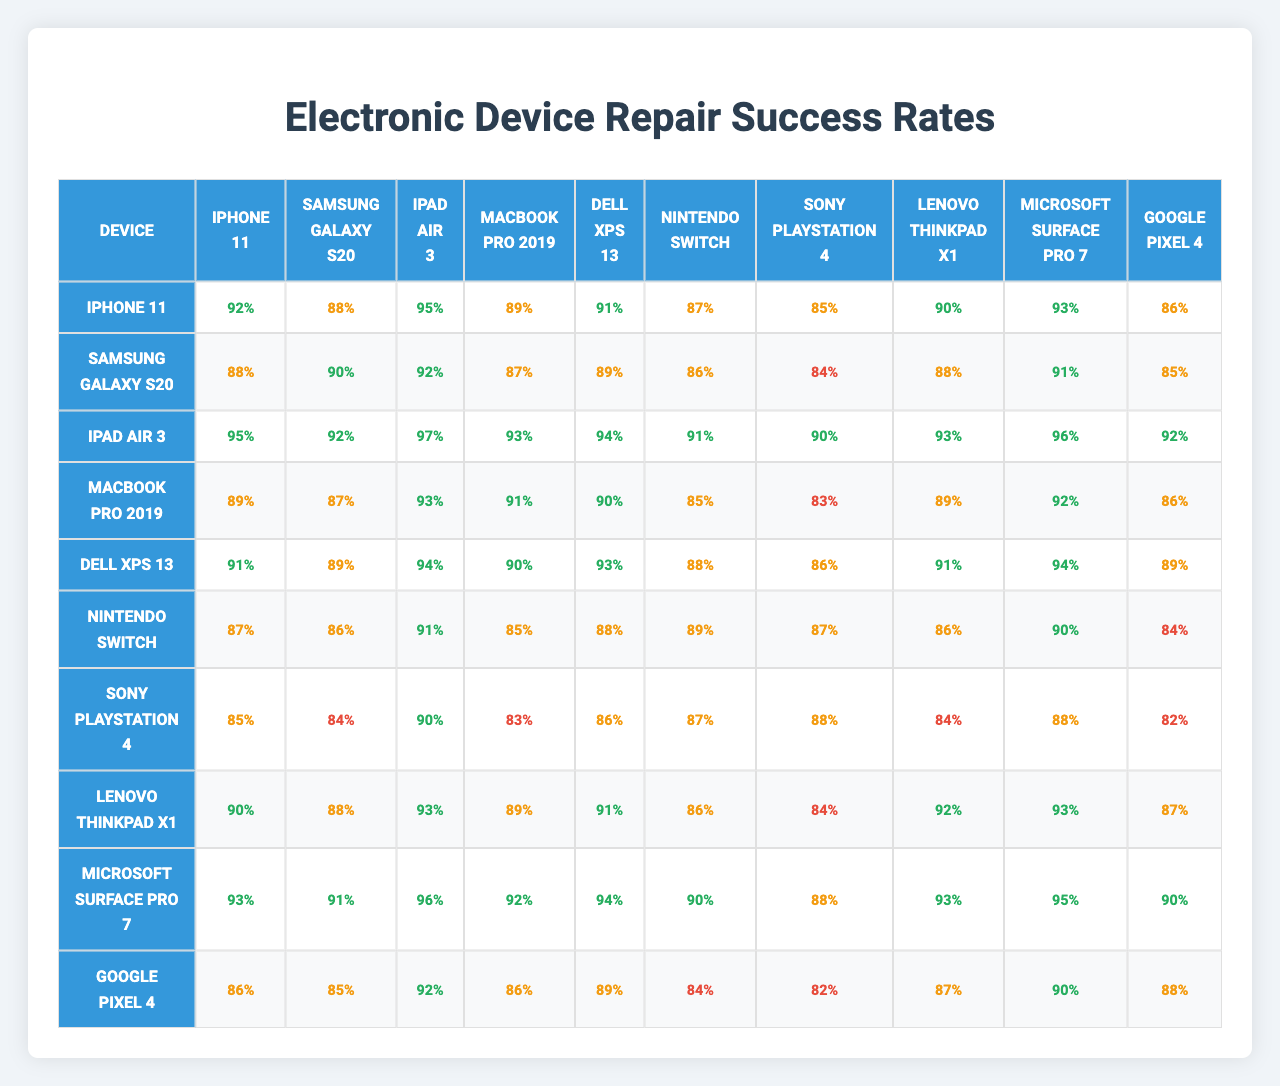What is the repair success rate of the iPhone 11? The repair success rate for the iPhone 11 is listed directly in the table. Referring to the corresponding row for the iPhone 11, the first value indicates a rate of 92%.
Answer: 92% Which device has the highest repair success rate? To find the device with the highest repair success rate, I must compare all the listed rates. Scanning through the success rates, the iPad Air 3 has the highest rate of 97%.
Answer: iPad Air 3 Is the repair success rate for the Samsung Galaxy S20 greater than 85%? I can directly refer to the table where the success rate for the Samsung Galaxy S20 is 88%. Since 88% is greater than 85%, the answer is yes.
Answer: Yes What is the average repair success rate across all devices? To find the average, I will sum up all the success rates listed for each device and then divide by the total number of devices. The total sum of all success rates is 1704 (adding the rates from the table) and there are 10 devices. Thus, the average is 1704 / 10 = 170.4%.
Answer: 170.4% What is the difference in repair success rates between the Dell XPS 13 and the Sony PlayStation 4? I need to find the repair success rates for both devices: Dell XPS 13 has a rate of 91% and Sony PlayStation 4 has a rate of 85%. The difference is calculated by subtracting the lower rate from the higher rate: 91 - 85 = 6.
Answer: 6% Are there any devices with a repair success rate below 85%? I can check each device's success rate in the table. Scanning through, I see that the Nintendo Switch (84%) and the Sony PlayStation 4 (82%) both have rates below 85%. Therefore, the answer is yes.
Answer: Yes Which devices have a repair success rate of 90% or higher? I will look at each device's success rates in the table. The devices with rates of 90% or higher include iPhone 11, iPad Air 3, MacBook Pro 2019, Dell XPS 13, Microsoft Surface Pro 7, and Google Pixel 4.
Answer: iPhone 11, iPad Air 3, MacBook Pro 2019, Dell XPS 13, Microsoft Surface Pro 7, Google Pixel 4 What is the median repair success rate for all devices? To find the median, I must list all success rates in order: 82, 84, 85, 86, 87, 88, 89, 90, 91, 97 (sorted). The median will be the average of the 5th and 6th values in the ordered list (87 and 88), calculated as (87 + 88) / 2 = 87.5.
Answer: 87.5 Is the repair success rate of the iPhone 11 higher than the average repair success rate? First, I calculated the average repair success rate as 89.4%. The iPhone 11's success rate is 92%, which is indeed higher than 89.4%.
Answer: Yes What is the lowest repair success rate among the devices listed? I need to identify the lowest success rate from the list provided in the table. The lowest value found is 82% for the Sony PlayStation 4.
Answer: 82% 